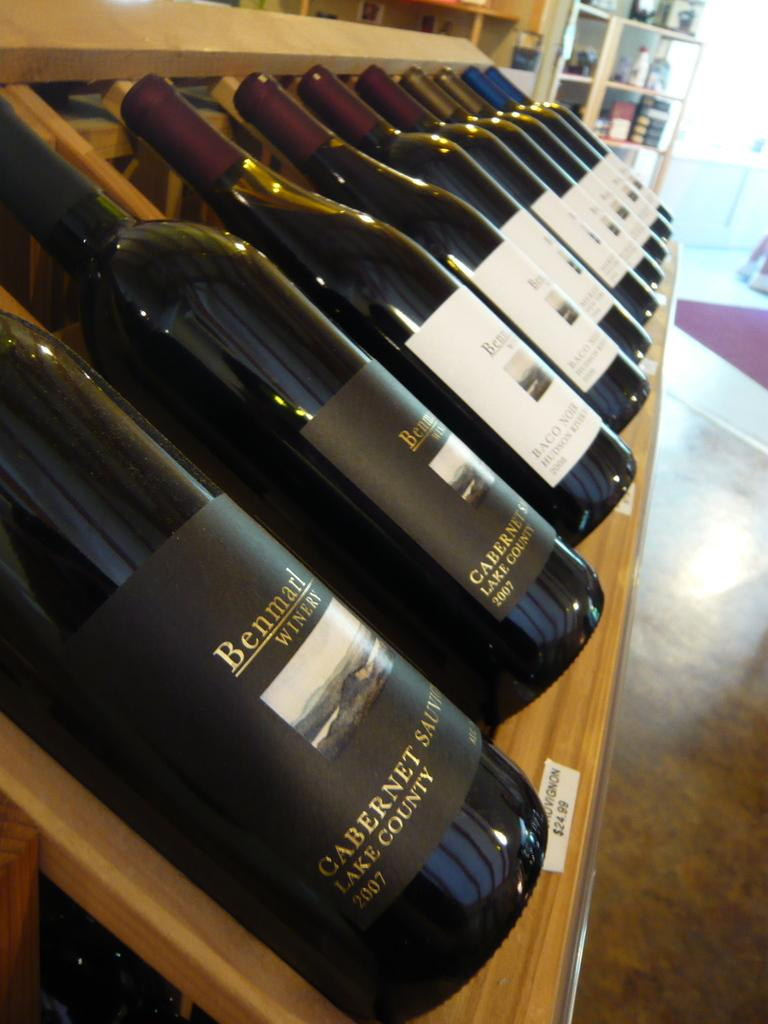What objects are on the wooden surface in the image? There are bottles on a wooden surface in the image. Can you describe the wooden rack in the background of the image? There are bottles on it? How does the structure help the brother in the image? There is no structure or brother present in the image; it only features bottles on a wooden surface and a wooden rack in the background. 